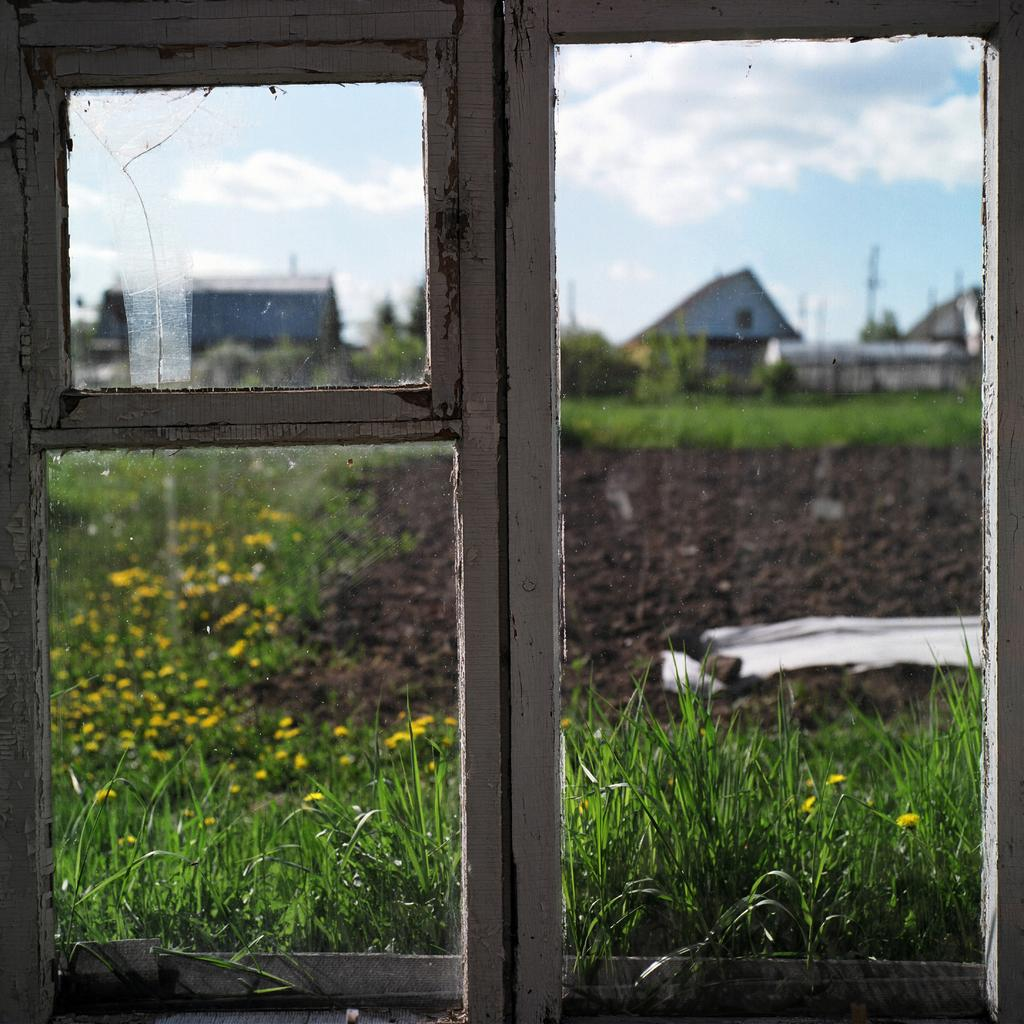What can be seen through the window in the image? Grassland, soil, houses, and the sky are visible through the window in the image. What material is used for the window panes? The window panes are made of glass. How many different elements can be seen through the window? Five different elements can be seen through the window: grassland, soil, houses, and the sky. What type of waste can be seen on someone's wrist in the image? There is no waste or reference to a wrist in the image; it only features a window with various elements visible through it. 